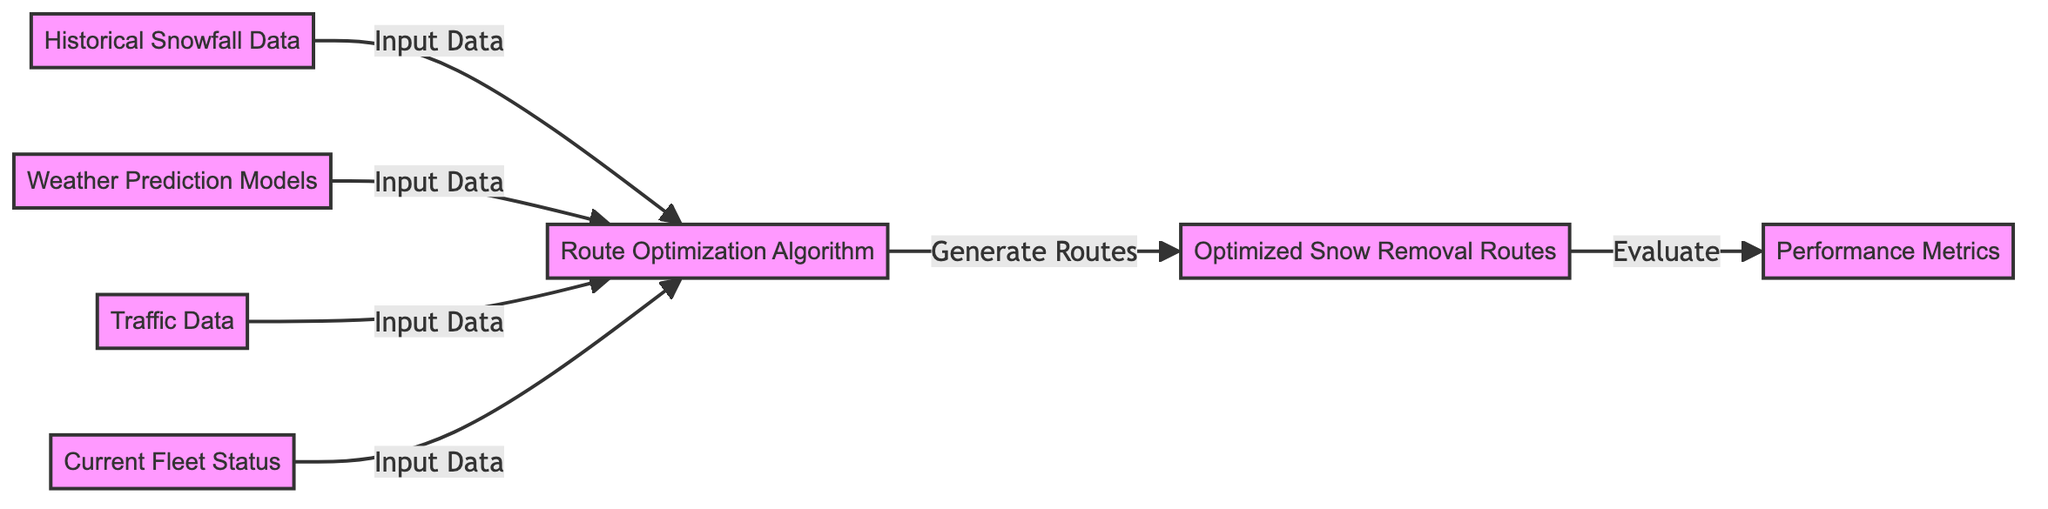What is the final output node of the diagram? The final output node is "Optimized Snow Removal Routes," which is where the process concludes after generating routes.
Answer: Optimized Snow Removal Routes How many input data nodes are there? There are four input data nodes: "Historical Snowfall Data," "Weather Prediction Models," "Traffic Data," and "Current Fleet Status."
Answer: Four What links the "Route Optimization Algorithm" to the "Optimized Snow Removal Routes"? The link labeled "Generate Routes" connects the "Route Optimization Algorithm" to the "Optimized Snow Removal Routes," indicating that the algorithm produces the routes based on inputs.
Answer: Generate Routes What is evaluated after the optimized routes are generated? The output is evaluated using "Performance Metrics," which are measuring the effectiveness or efficiency of the optimized routes.
Answer: Performance Metrics What type of data is inputted into the "Route Optimization Algorithm"? The algorithm receives input data from four different sources: historical snowfall data, weather prediction models, traffic data, and current fleet status.
Answer: Historical snowfall data, weather prediction models, traffic data, and current fleet status What is the purpose of "Performance Metrics" in this diagram? "Performance Metrics" assess or evaluate the efficiency or success of the "Optimized Snow Removal Routes" generated by the algorithm.
Answer: Evaluate Which node directly inputs data into the "Route Optimization Algorithm"? All four nodes: "Historical Snowfall Data," "Weather Prediction Models," "Traffic Data," and "Current Fleet Status" directly input data into the "Route Optimization Algorithm."
Answer: Historical Snowfall Data, Weather Prediction Models, Traffic Data, and Current Fleet Status How many total nodes are present in the diagram? There are seven total nodes displayed in the diagram, including both input and output nodes.
Answer: Seven 